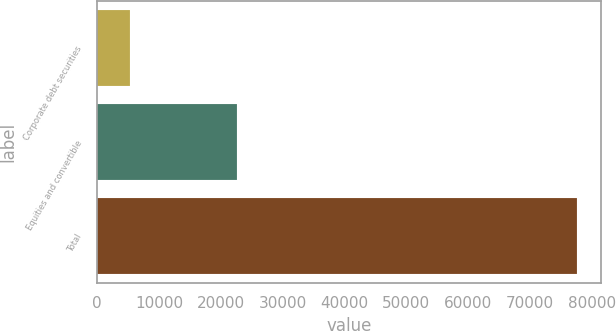<chart> <loc_0><loc_0><loc_500><loc_500><bar_chart><fcel>Corporate debt securities<fcel>Equities and convertible<fcel>Total<nl><fcel>5253<fcel>22583<fcel>77704<nl></chart> 